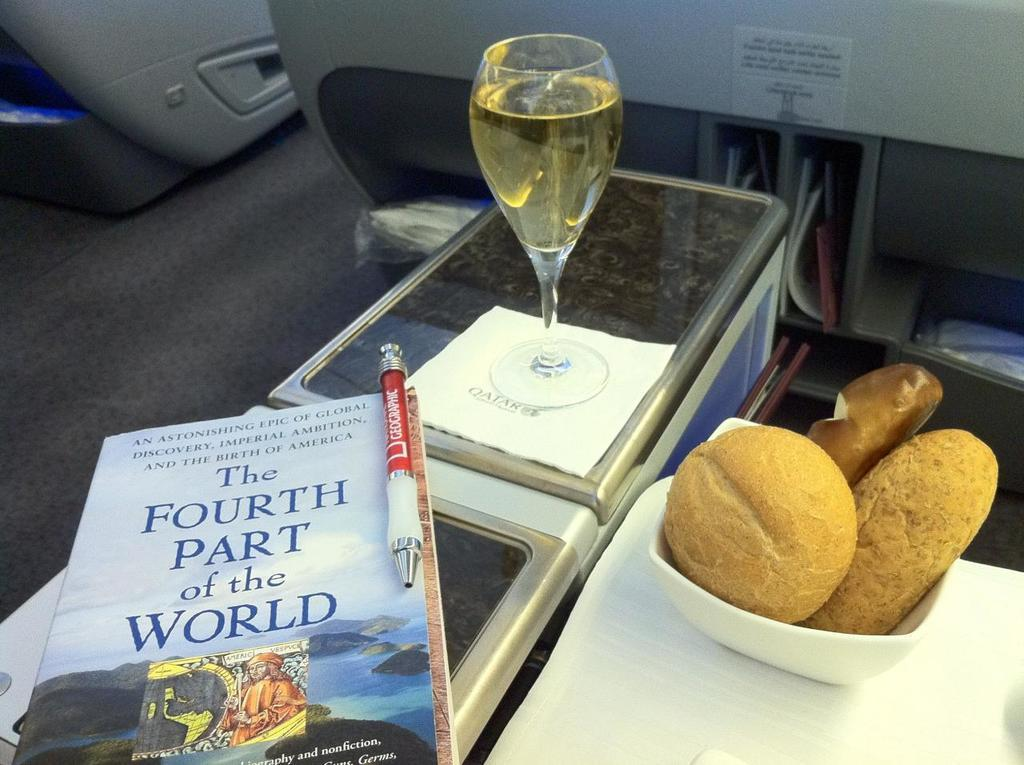<image>
Create a compact narrative representing the image presented. A traveler is free to avail themselves of food, drink and/or an interesting book about America's birth. 